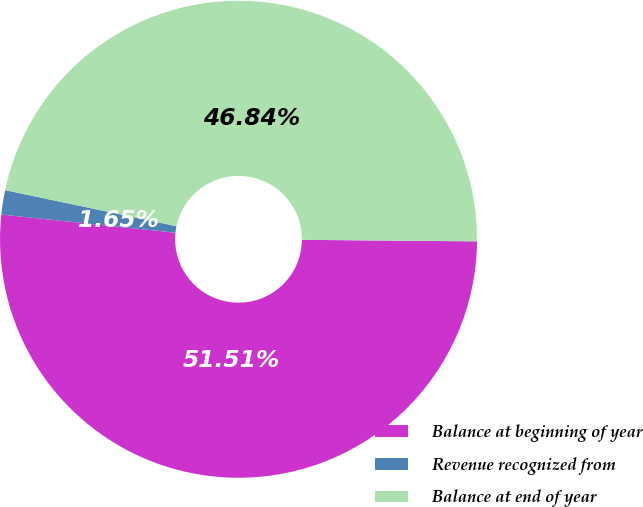<chart> <loc_0><loc_0><loc_500><loc_500><pie_chart><fcel>Balance at beginning of year<fcel>Revenue recognized from<fcel>Balance at end of year<nl><fcel>51.52%<fcel>1.65%<fcel>46.84%<nl></chart> 